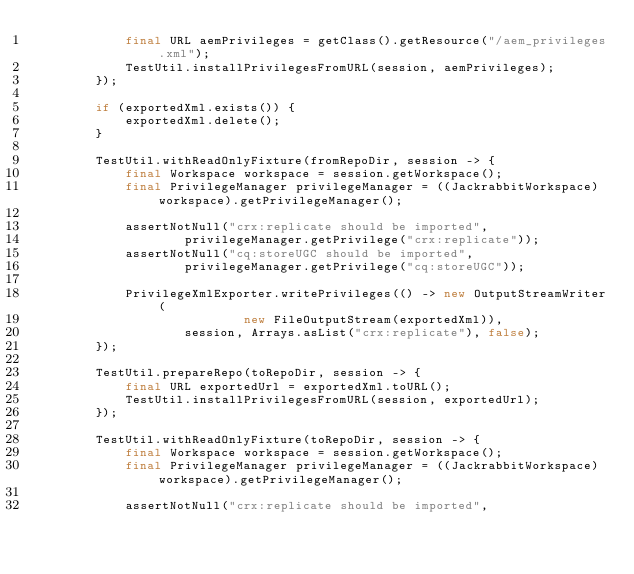<code> <loc_0><loc_0><loc_500><loc_500><_Java_>            final URL aemPrivileges = getClass().getResource("/aem_privileges.xml");
            TestUtil.installPrivilegesFromURL(session, aemPrivileges);
        });

        if (exportedXml.exists()) {
            exportedXml.delete();
        }

        TestUtil.withReadOnlyFixture(fromRepoDir, session -> {
            final Workspace workspace = session.getWorkspace();
            final PrivilegeManager privilegeManager = ((JackrabbitWorkspace) workspace).getPrivilegeManager();

            assertNotNull("crx:replicate should be imported",
                    privilegeManager.getPrivilege("crx:replicate"));
            assertNotNull("cq:storeUGC should be imported",
                    privilegeManager.getPrivilege("cq:storeUGC"));

            PrivilegeXmlExporter.writePrivileges(() -> new OutputStreamWriter(
                            new FileOutputStream(exportedXml)),
                    session, Arrays.asList("crx:replicate"), false);
        });

        TestUtil.prepareRepo(toRepoDir, session -> {
            final URL exportedUrl = exportedXml.toURL();
            TestUtil.installPrivilegesFromURL(session, exportedUrl);
        });

        TestUtil.withReadOnlyFixture(toRepoDir, session -> {
            final Workspace workspace = session.getWorkspace();
            final PrivilegeManager privilegeManager = ((JackrabbitWorkspace) workspace).getPrivilegeManager();

            assertNotNull("crx:replicate should be imported",</code> 